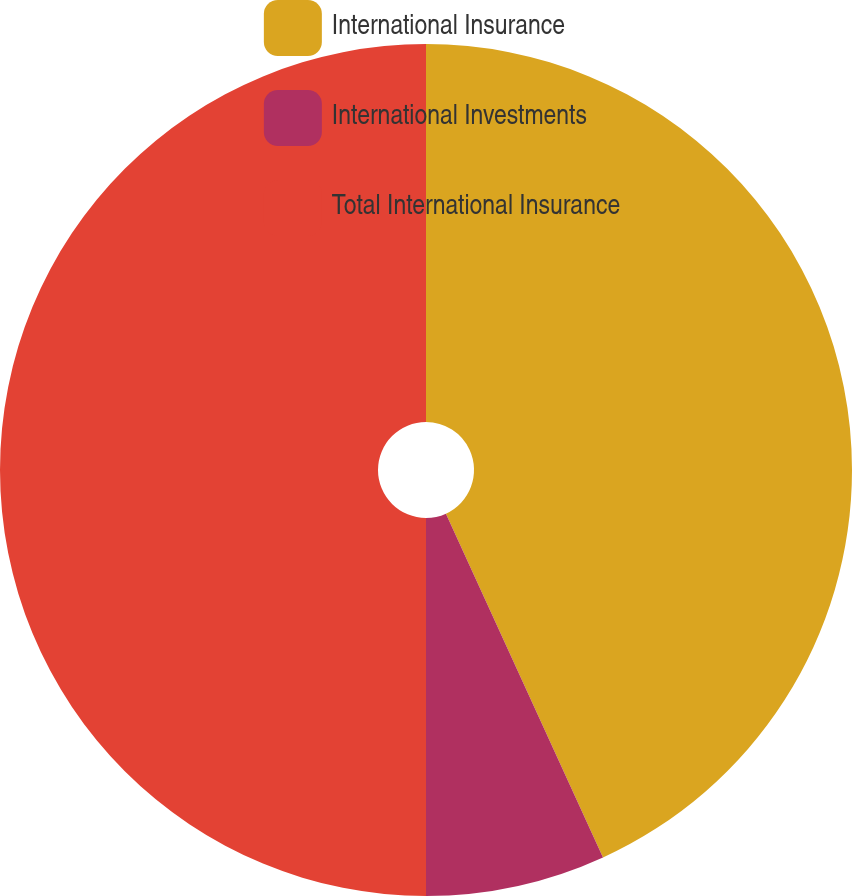<chart> <loc_0><loc_0><loc_500><loc_500><pie_chart><fcel>International Insurance<fcel>International Investments<fcel>Total International Insurance<nl><fcel>43.18%<fcel>6.82%<fcel>50.0%<nl></chart> 